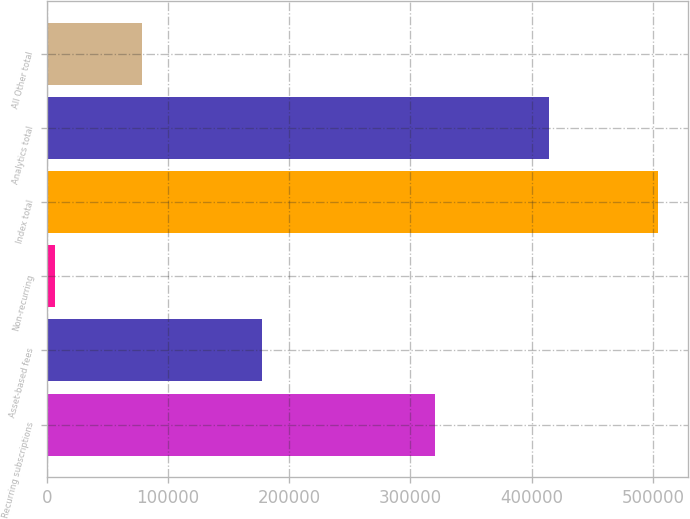Convert chart to OTSL. <chart><loc_0><loc_0><loc_500><loc_500><bar_chart><fcel>Recurring subscriptions<fcel>Asset-based fees<fcel>Non-recurring<fcel>Index total<fcel>Analytics total<fcel>All Other total<nl><fcel>320113<fcel>177105<fcel>6674<fcel>503892<fcel>414085<fcel>78703<nl></chart> 